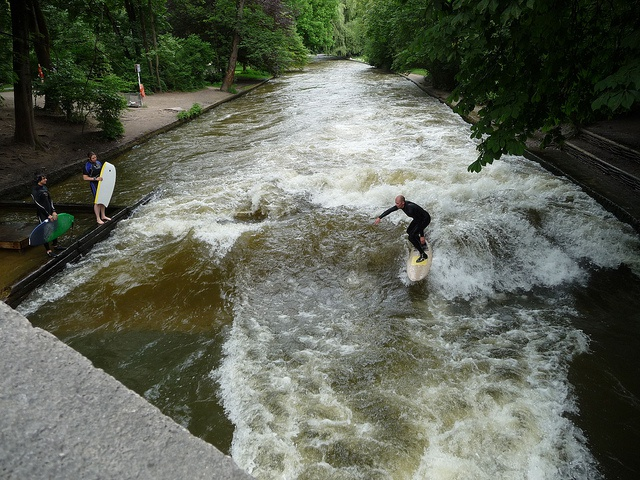Describe the objects in this image and their specific colors. I can see people in black, darkgray, gray, and brown tones, people in black, gray, brown, and maroon tones, people in black, gray, and navy tones, surfboard in black, darkgreen, and teal tones, and surfboard in black, lightgray, and darkgray tones in this image. 